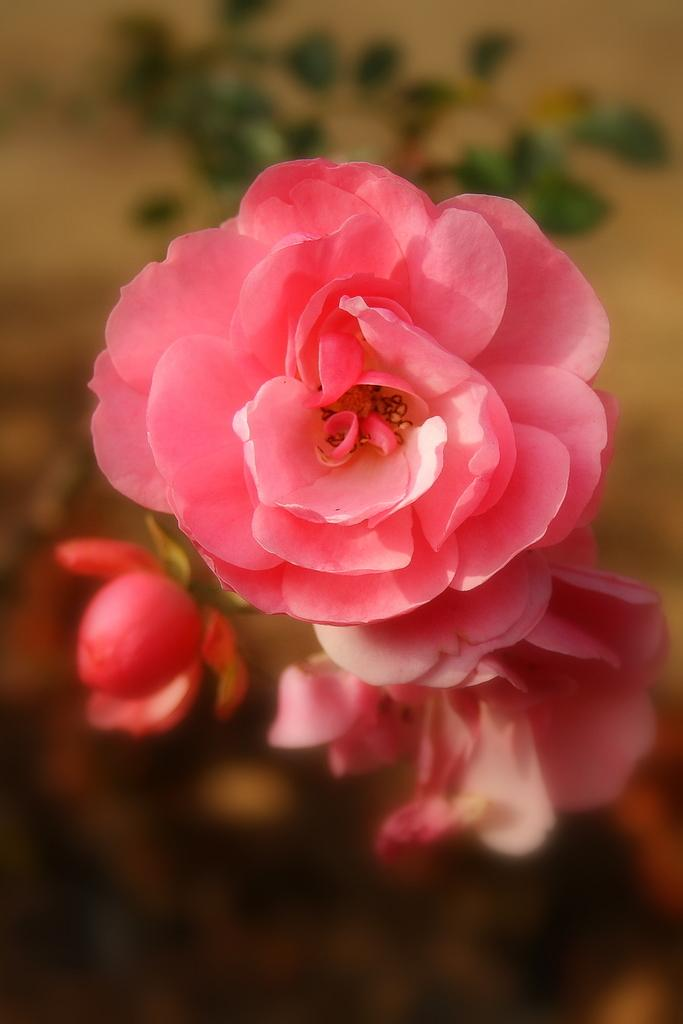What type of flowers are in the image? There are rose flowers in the image. What color are the rose flowers? The rose flowers are pink in color. Can you describe any specific stage of the rose flowers in the image? There is a rose bud in the image. What can be seen in the background of the image? There are plants in the background of the image. How many times did the person kick the rose flower in the image? There is no person kicking the rose flower in the image; it is a still image of the flowers. 